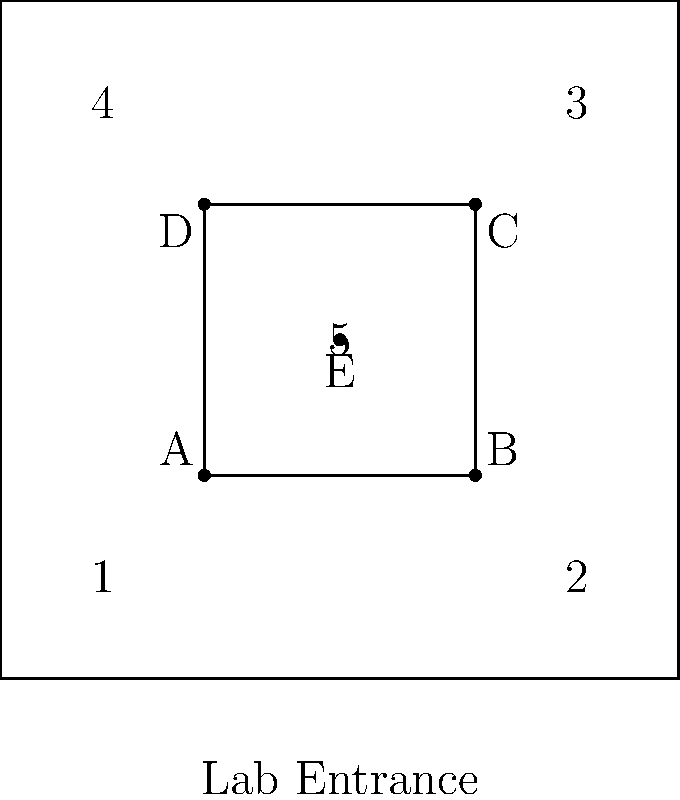Given the layout of a biomedical research laboratory shown above, where:
1. PCR machine
2. Centrifuge
3. Incubator
4. Microscope
5. Biosafety cabinet

What is the optimal arrangement of these pieces of equipment to minimize movement and maximize workflow efficiency in precision medicine experiments? Provide the correct order of equipment placement for positions A, B, C, D, and E. To optimize the layout for efficient workflow in precision medicine experiments, we need to consider the typical sequence of operations and the frequency of use for each piece of equipment. Let's approach this step-by-step:

1. The biosafety cabinet (5) should be placed centrally (position E) as it's crucial for maintaining sterile conditions and is frequently used in various stages of experiments.

2. The PCR machine (1) and centrifuge (2) are often used in sequence for DNA amplification and separation. They should be placed close to each other, preferably at positions A and B near the entrance for easy access.

3. The incubator (3) is used for cell culture and should be placed away from high-traffic areas to minimize temperature fluctuations. Position C, furthest from the entrance, is ideal.

4. The microscope (4) is used for sample analysis and should be placed in a quieter area of the lab, making position D suitable.

This arrangement minimizes movement by:
- Placing frequently used equipment (PCR machine, centrifuge) near the entrance
- Positioning the biosafety cabinet centrally for easy access from all areas
- Keeping the incubator away from high-traffic areas
- Placing the microscope in a quieter corner for focused analysis

The optimal arrangement is:
A: PCR machine (1)
B: Centrifuge (2)
C: Incubator (3)
D: Microscope (4)
E: Biosafety cabinet (5)
Answer: 1-A, 2-B, 3-C, 4-D, 5-E 